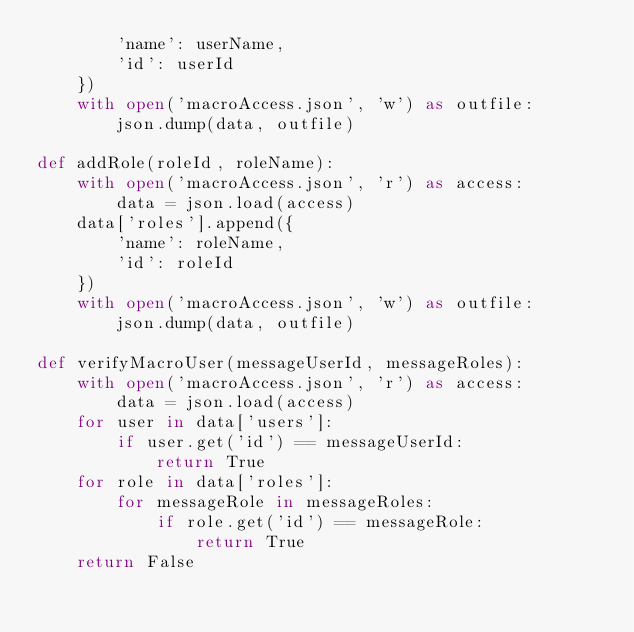Convert code to text. <code><loc_0><loc_0><loc_500><loc_500><_Python_>        'name': userName,
        'id': userId
    })
    with open('macroAccess.json', 'w') as outfile:
        json.dump(data, outfile)

def addRole(roleId, roleName):
    with open('macroAccess.json', 'r') as access:
        data = json.load(access)
    data['roles'].append({
        'name': roleName,
        'id': roleId
    })
    with open('macroAccess.json', 'w') as outfile:
        json.dump(data, outfile)

def verifyMacroUser(messageUserId, messageRoles):
    with open('macroAccess.json', 'r') as access:
        data = json.load(access)
    for user in data['users']:
        if user.get('id') == messageUserId:
            return True
    for role in data['roles']:
        for messageRole in messageRoles:
            if role.get('id') == messageRole:
                return True
    return False
    </code> 